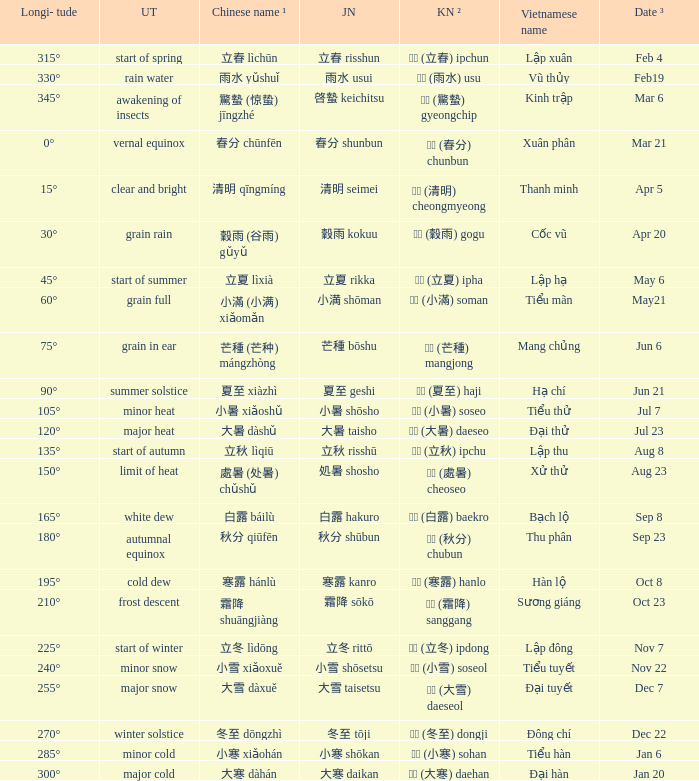WHich Usual translation is on sep 23? Autumnal equinox. 